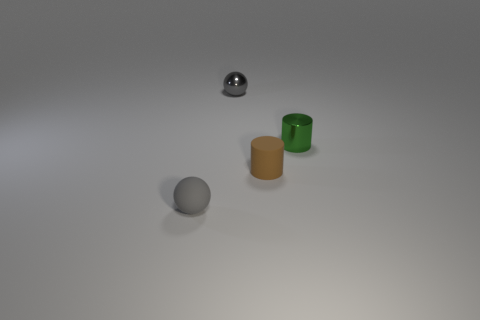The metal ball that is the same color as the matte sphere is what size?
Ensure brevity in your answer.  Small. What number of red objects are either metal things or matte objects?
Your answer should be compact. 0. What number of other objects are the same shape as the tiny brown thing?
Ensure brevity in your answer.  1. Do the small ball that is behind the tiny matte ball and the cylinder that is on the right side of the tiny brown rubber cylinder have the same color?
Keep it short and to the point. No. How many big things are either metal cylinders or gray balls?
Make the answer very short. 0. What size is the other thing that is the same shape as the brown thing?
Offer a very short reply. Small. The gray thing that is right of the small ball in front of the brown rubber cylinder is made of what material?
Provide a succinct answer. Metal. What number of metal things are either cubes or small spheres?
Provide a short and direct response. 1. The other tiny metal object that is the same shape as the brown thing is what color?
Provide a succinct answer. Green. How many small cylinders have the same color as the small metallic ball?
Give a very brief answer. 0. 